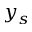Convert formula to latex. <formula><loc_0><loc_0><loc_500><loc_500>y _ { s }</formula> 